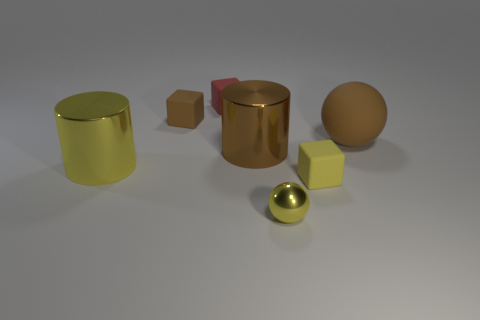Subtract all brown cubes. How many cubes are left? 2 Add 1 big blue rubber balls. How many objects exist? 8 Subtract all blocks. How many objects are left? 4 Add 4 tiny rubber objects. How many tiny rubber objects are left? 7 Add 1 yellow balls. How many yellow balls exist? 2 Subtract 0 cyan spheres. How many objects are left? 7 Subtract all blue blocks. Subtract all purple cylinders. How many blocks are left? 3 Subtract all spheres. Subtract all small yellow matte cubes. How many objects are left? 4 